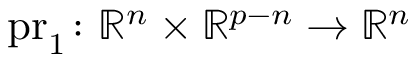Convert formula to latex. <formula><loc_0><loc_0><loc_500><loc_500>{ p r _ { 1 } } \colon { \mathbb { R } ^ { n } } \times { \mathbb { R } ^ { p - n } } \to { \mathbb { R } ^ { n } }</formula> 